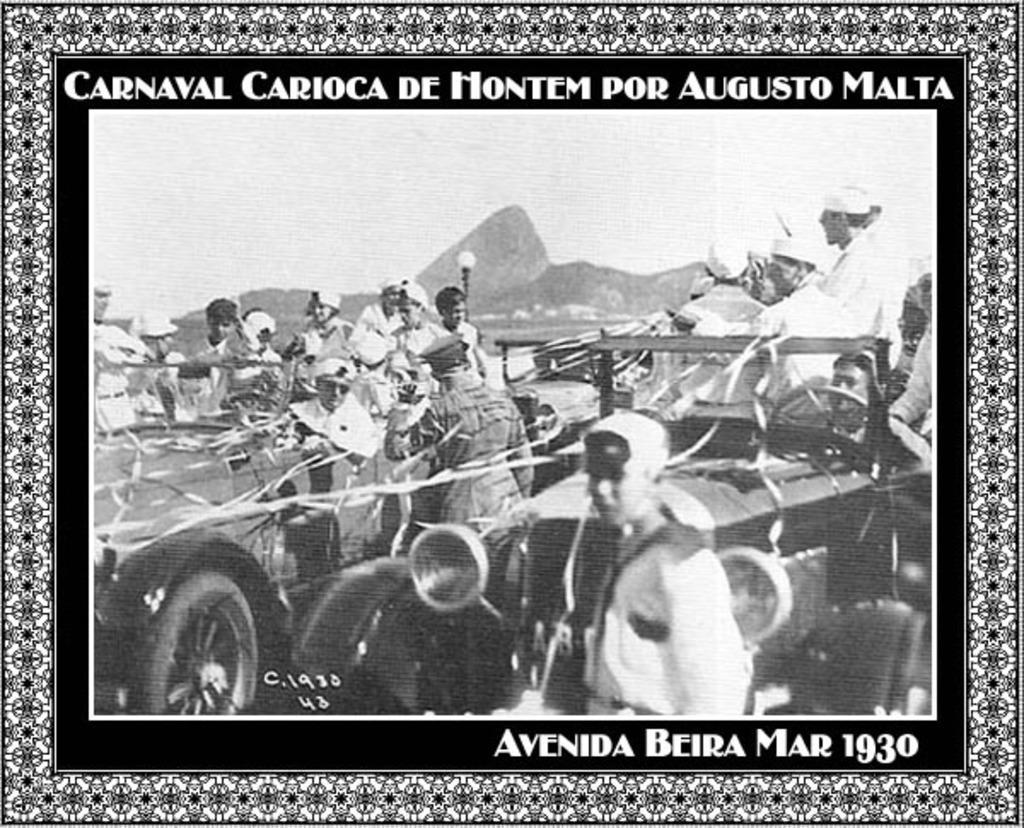How would you summarize this image in a sentence or two? This is a poster which is having texts, an image and a border which is having a design. In the image, there are persons in the vehicles. Beside them, there is a person. In the background, there are mountains and there is sky. 